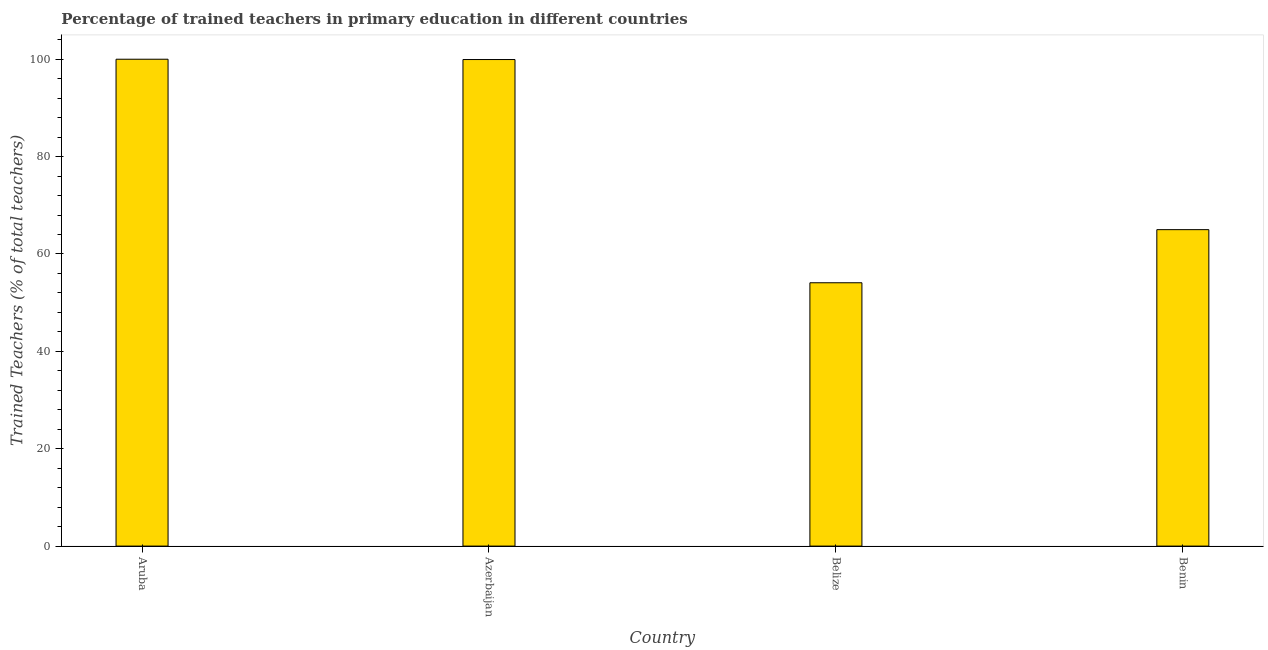Does the graph contain any zero values?
Your answer should be compact. No. Does the graph contain grids?
Offer a very short reply. No. What is the title of the graph?
Your answer should be compact. Percentage of trained teachers in primary education in different countries. What is the label or title of the X-axis?
Keep it short and to the point. Country. What is the label or title of the Y-axis?
Provide a succinct answer. Trained Teachers (% of total teachers). What is the percentage of trained teachers in Azerbaijan?
Your response must be concise. 99.93. Across all countries, what is the minimum percentage of trained teachers?
Make the answer very short. 54.09. In which country was the percentage of trained teachers maximum?
Your response must be concise. Aruba. In which country was the percentage of trained teachers minimum?
Your response must be concise. Belize. What is the sum of the percentage of trained teachers?
Your response must be concise. 319.02. What is the difference between the percentage of trained teachers in Aruba and Benin?
Give a very brief answer. 35. What is the average percentage of trained teachers per country?
Make the answer very short. 79.75. What is the median percentage of trained teachers?
Give a very brief answer. 82.47. In how many countries, is the percentage of trained teachers greater than 28 %?
Offer a very short reply. 4. What is the ratio of the percentage of trained teachers in Aruba to that in Benin?
Provide a succinct answer. 1.54. Is the percentage of trained teachers in Azerbaijan less than that in Belize?
Your answer should be compact. No. Is the difference between the percentage of trained teachers in Azerbaijan and Belize greater than the difference between any two countries?
Your answer should be very brief. No. What is the difference between the highest and the second highest percentage of trained teachers?
Ensure brevity in your answer.  0.07. What is the difference between the highest and the lowest percentage of trained teachers?
Provide a succinct answer. 45.91. In how many countries, is the percentage of trained teachers greater than the average percentage of trained teachers taken over all countries?
Your answer should be compact. 2. How many bars are there?
Ensure brevity in your answer.  4. Are the values on the major ticks of Y-axis written in scientific E-notation?
Offer a very short reply. No. What is the Trained Teachers (% of total teachers) of Azerbaijan?
Offer a very short reply. 99.93. What is the Trained Teachers (% of total teachers) of Belize?
Make the answer very short. 54.09. What is the Trained Teachers (% of total teachers) in Benin?
Ensure brevity in your answer.  65. What is the difference between the Trained Teachers (% of total teachers) in Aruba and Azerbaijan?
Give a very brief answer. 0.07. What is the difference between the Trained Teachers (% of total teachers) in Aruba and Belize?
Ensure brevity in your answer.  45.91. What is the difference between the Trained Teachers (% of total teachers) in Aruba and Benin?
Your answer should be very brief. 35. What is the difference between the Trained Teachers (% of total teachers) in Azerbaijan and Belize?
Keep it short and to the point. 45.85. What is the difference between the Trained Teachers (% of total teachers) in Azerbaijan and Benin?
Offer a terse response. 34.94. What is the difference between the Trained Teachers (% of total teachers) in Belize and Benin?
Your response must be concise. -10.91. What is the ratio of the Trained Teachers (% of total teachers) in Aruba to that in Belize?
Provide a short and direct response. 1.85. What is the ratio of the Trained Teachers (% of total teachers) in Aruba to that in Benin?
Your answer should be compact. 1.54. What is the ratio of the Trained Teachers (% of total teachers) in Azerbaijan to that in Belize?
Your answer should be very brief. 1.85. What is the ratio of the Trained Teachers (% of total teachers) in Azerbaijan to that in Benin?
Provide a short and direct response. 1.54. What is the ratio of the Trained Teachers (% of total teachers) in Belize to that in Benin?
Offer a terse response. 0.83. 